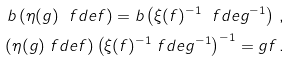Convert formula to latex. <formula><loc_0><loc_0><loc_500><loc_500>b \left ( \eta ( g ) \ f d e f \right ) = b \left ( \xi ( f ) ^ { - 1 } \ f d e g ^ { - 1 } \right ) \, , \\ \left ( \eta ( g ) \ f d e f \right ) \left ( \xi ( f ) ^ { - 1 } \ f d e g ^ { - 1 } \right ) ^ { - 1 } = g f \, .</formula> 